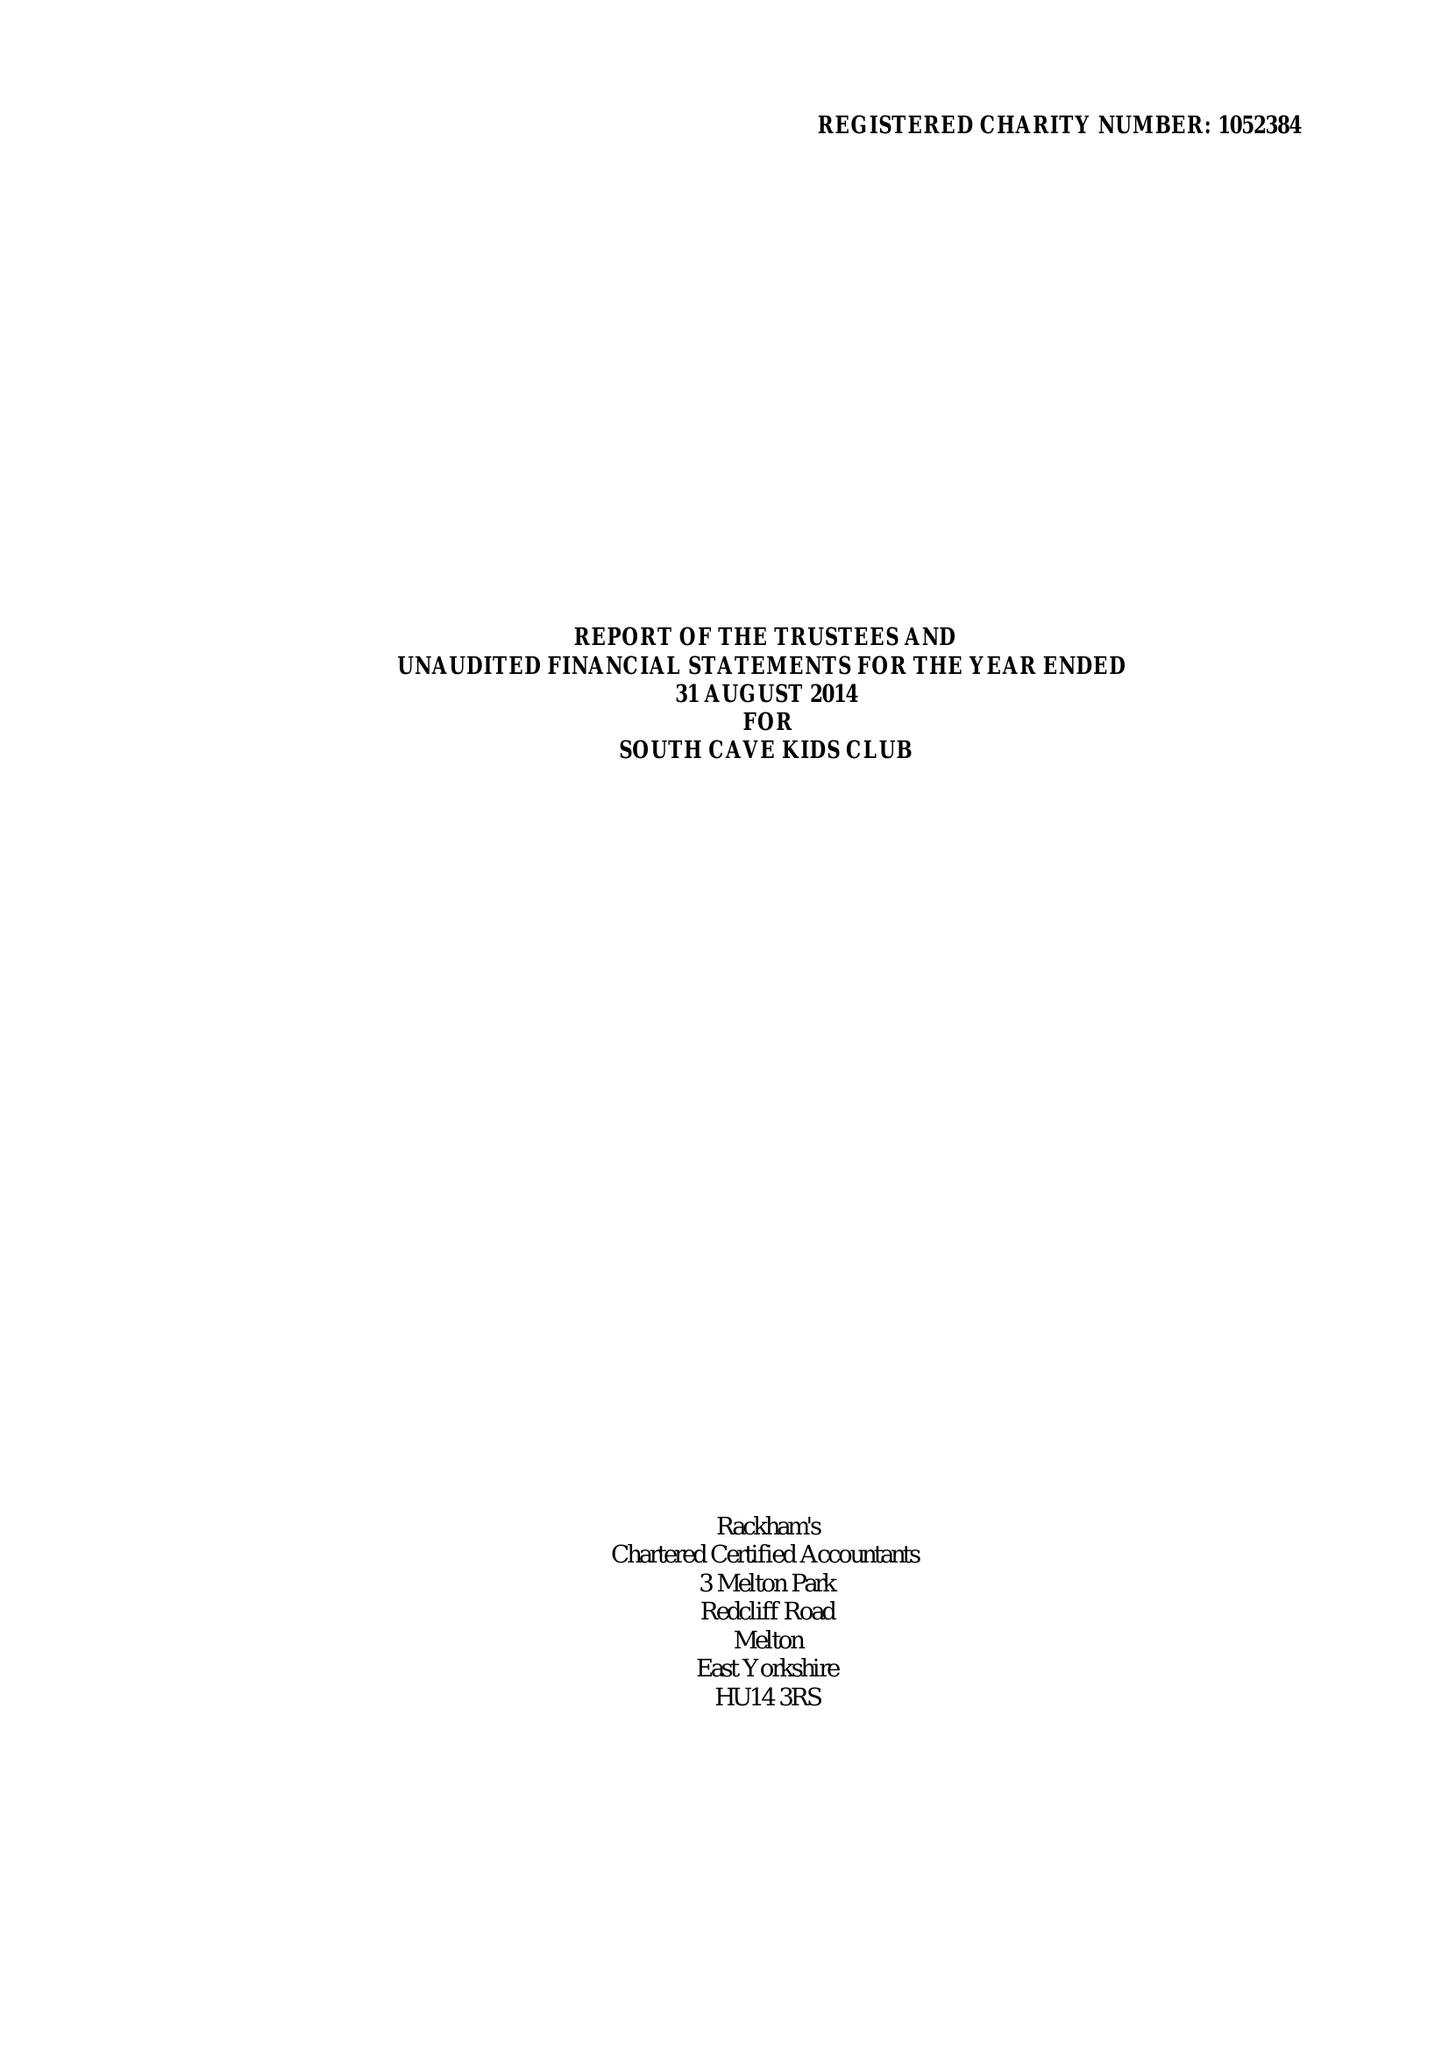What is the value for the address__postcode?
Answer the question using a single word or phrase. HU15 2EP 